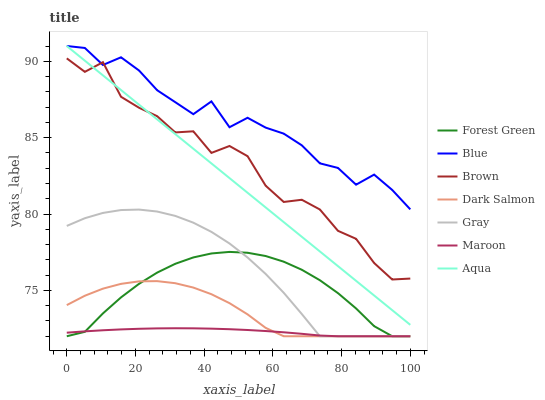Does Maroon have the minimum area under the curve?
Answer yes or no. Yes. Does Blue have the maximum area under the curve?
Answer yes or no. Yes. Does Brown have the minimum area under the curve?
Answer yes or no. No. Does Brown have the maximum area under the curve?
Answer yes or no. No. Is Aqua the smoothest?
Answer yes or no. Yes. Is Brown the roughest?
Answer yes or no. Yes. Is Gray the smoothest?
Answer yes or no. No. Is Gray the roughest?
Answer yes or no. No. Does Gray have the lowest value?
Answer yes or no. Yes. Does Brown have the lowest value?
Answer yes or no. No. Does Aqua have the highest value?
Answer yes or no. Yes. Does Brown have the highest value?
Answer yes or no. No. Is Dark Salmon less than Brown?
Answer yes or no. Yes. Is Aqua greater than Dark Salmon?
Answer yes or no. Yes. Does Dark Salmon intersect Maroon?
Answer yes or no. Yes. Is Dark Salmon less than Maroon?
Answer yes or no. No. Is Dark Salmon greater than Maroon?
Answer yes or no. No. Does Dark Salmon intersect Brown?
Answer yes or no. No. 